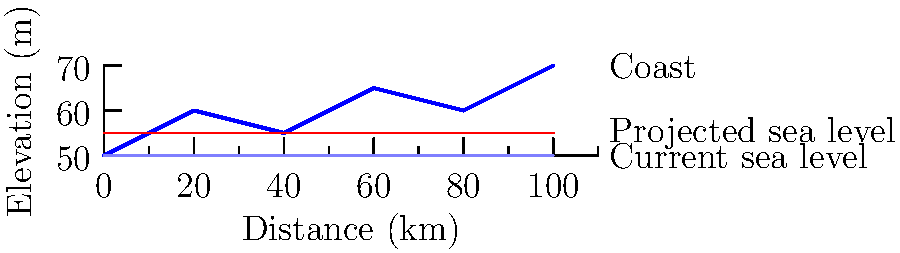Based on the topographical map of Oregon's coastline, what percentage of the shown coastal area is projected to be submerged due to sea level rise caused by climate change? To determine the percentage of the coastal area that will be submerged:

1. Observe the current sea level (light blue line) and the projected sea level (red line).
2. Calculate the total coastal area shown:
   - Approximate area above current sea level = 100 km * 20 m = 2000 km*m
3. Estimate the area that will be submerged:
   - Average increase in sea level = 5 m
   - Submerged area = 100 km * 5 m = 500 km*m
4. Calculate the percentage:
   $\frac{\text{Submerged area}}{\text{Total area}} \times 100\% = \frac{500}{2000} \times 100\% = 25\%$

Therefore, approximately 25% of the shown coastal area is projected to be submerged.
Answer: 25% 